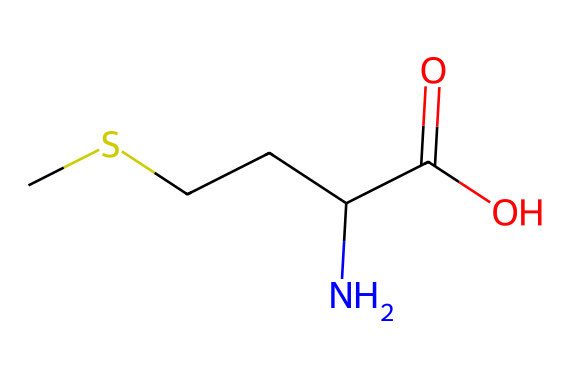What is the total number of carbon atoms in this compound? By examining the SMILES representation, we can identify that "C" stands for carbon atoms. There are 4 "C" entries in the SMILES structure, indicating there are 4 carbon atoms present.
Answer: 4 How many nitrogen atoms are present in the structure? The SMILES contains one "N" representing nitrogen atoms. Thus, there is only one nitrogen atom in this compound.
Answer: 1 What functional groups are present in this compound? Analyzing the SMILES representation, we can identify the presence of a carboxylic acid functional group (due to C(=O)O) and an amine group (due to the "N"). Hence, the compound contains both a carboxylic acid and an amine functional group.
Answer: carboxylic acid and amine Which part of the structure contains sulfur? In the SMILES representation, however, we can see that while the compound is an organosulfur compound, sulfur is not explicitly represented in this SMILES. Thus, we conclude that there is no visible sulfur in this specific representation.
Answer: none How many hydrogen atoms are implied in this structure? To find the number of hydrogen atoms, we calculate based on the tetravalency of carbon and the presence of bonds. Each carbon typically bonds with 4 total atoms. Given the structure, we see the number of hydrogen atoms implied is 9 after considering bonding with nitrogen and oxygen.
Answer: 9 Is this compound considered an amino acid? The presence of both an amine group and a carboxylic acid group, along with a side chain (the carbon chain), indicates that this compound meets the criteria for amino acids. Thus, it is indeed classified as one.
Answer: yes 